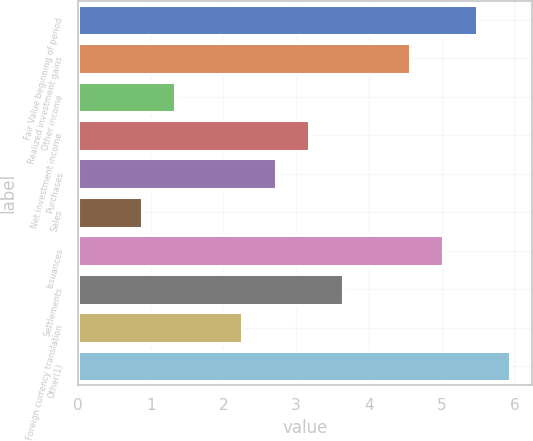Convert chart. <chart><loc_0><loc_0><loc_500><loc_500><bar_chart><fcel>Fair Value beginning of period<fcel>Realized investment gains<fcel>Other income<fcel>Net investment income<fcel>Purchases<fcel>Sales<fcel>Issuances<fcel>Settlements<fcel>Foreign currency translation<fcel>Other(1)<nl><fcel>5.48<fcel>4.56<fcel>1.34<fcel>3.18<fcel>2.72<fcel>0.88<fcel>5.02<fcel>3.64<fcel>2.26<fcel>5.94<nl></chart> 